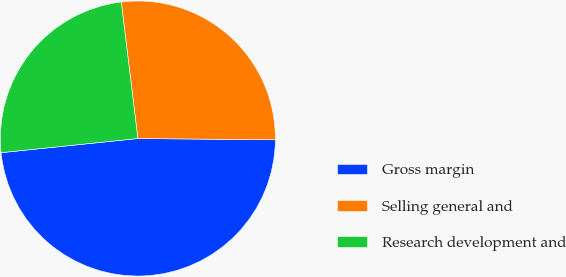Convert chart to OTSL. <chart><loc_0><loc_0><loc_500><loc_500><pie_chart><fcel>Gross margin<fcel>Selling general and<fcel>Research development and<nl><fcel>48.21%<fcel>27.07%<fcel>24.72%<nl></chart> 